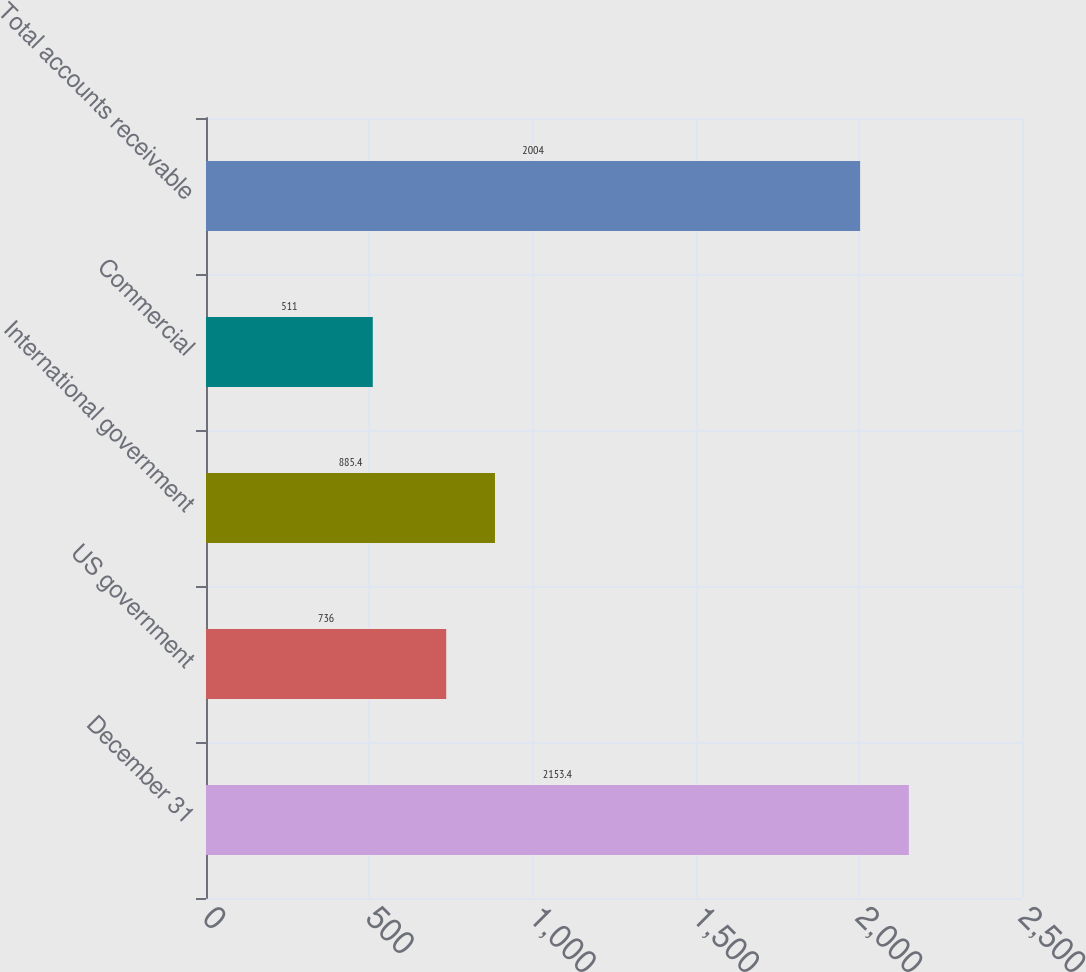Convert chart to OTSL. <chart><loc_0><loc_0><loc_500><loc_500><bar_chart><fcel>December 31<fcel>US government<fcel>International government<fcel>Commercial<fcel>Total accounts receivable<nl><fcel>2153.4<fcel>736<fcel>885.4<fcel>511<fcel>2004<nl></chart> 